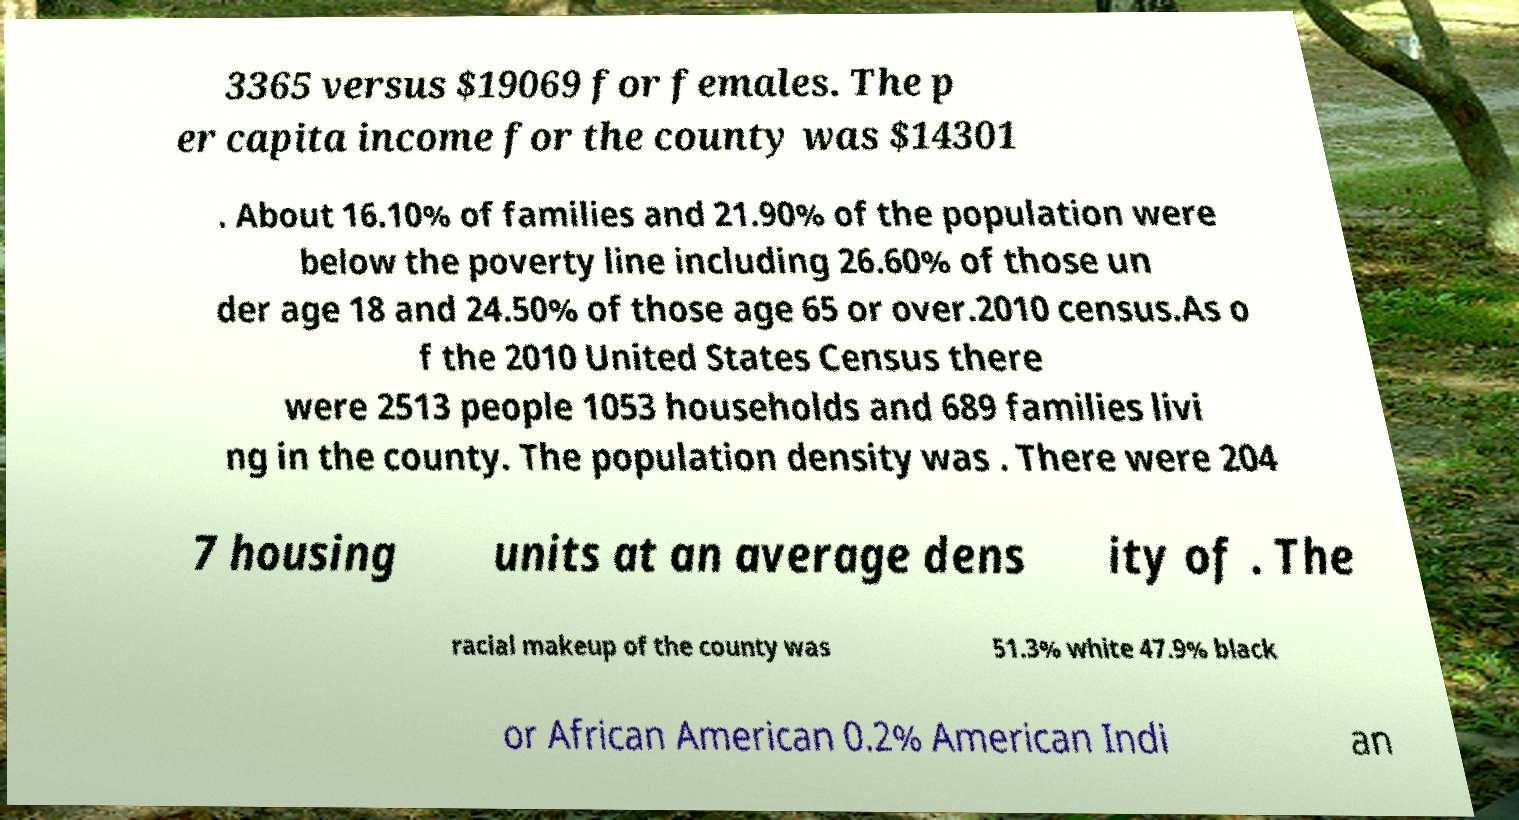I need the written content from this picture converted into text. Can you do that? 3365 versus $19069 for females. The p er capita income for the county was $14301 . About 16.10% of families and 21.90% of the population were below the poverty line including 26.60% of those un der age 18 and 24.50% of those age 65 or over.2010 census.As o f the 2010 United States Census there were 2513 people 1053 households and 689 families livi ng in the county. The population density was . There were 204 7 housing units at an average dens ity of . The racial makeup of the county was 51.3% white 47.9% black or African American 0.2% American Indi an 